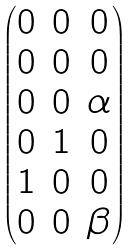Convert formula to latex. <formula><loc_0><loc_0><loc_500><loc_500>\begin{pmatrix} 0 & 0 & 0 \\ 0 & 0 & 0 \\ 0 & 0 & \alpha \\ 0 & 1 & 0 \\ 1 & 0 & 0 \\ 0 & 0 & \beta \end{pmatrix}</formula> 